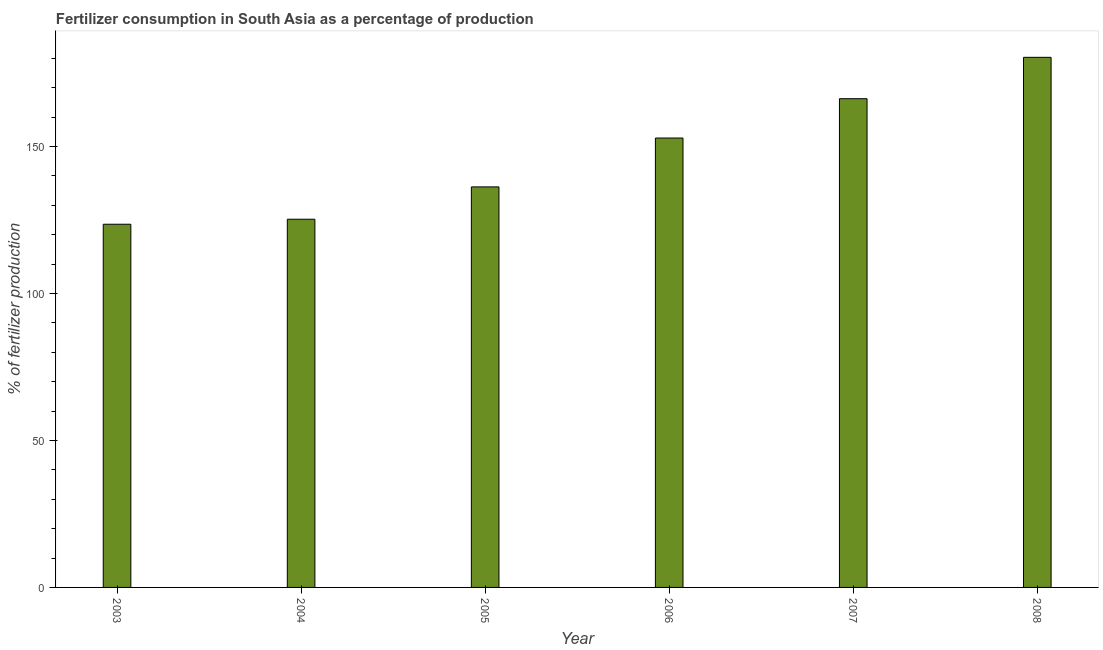Does the graph contain any zero values?
Make the answer very short. No. Does the graph contain grids?
Your response must be concise. No. What is the title of the graph?
Keep it short and to the point. Fertilizer consumption in South Asia as a percentage of production. What is the label or title of the X-axis?
Your answer should be compact. Year. What is the label or title of the Y-axis?
Provide a short and direct response. % of fertilizer production. What is the amount of fertilizer consumption in 2008?
Your answer should be very brief. 180.31. Across all years, what is the maximum amount of fertilizer consumption?
Offer a very short reply. 180.31. Across all years, what is the minimum amount of fertilizer consumption?
Give a very brief answer. 123.54. In which year was the amount of fertilizer consumption minimum?
Your response must be concise. 2003. What is the sum of the amount of fertilizer consumption?
Your response must be concise. 884.42. What is the difference between the amount of fertilizer consumption in 2003 and 2005?
Give a very brief answer. -12.7. What is the average amount of fertilizer consumption per year?
Your response must be concise. 147.4. What is the median amount of fertilizer consumption?
Provide a succinct answer. 144.55. What is the ratio of the amount of fertilizer consumption in 2006 to that in 2008?
Ensure brevity in your answer.  0.85. Is the difference between the amount of fertilizer consumption in 2005 and 2006 greater than the difference between any two years?
Offer a terse response. No. What is the difference between the highest and the second highest amount of fertilizer consumption?
Give a very brief answer. 14.07. Is the sum of the amount of fertilizer consumption in 2004 and 2007 greater than the maximum amount of fertilizer consumption across all years?
Provide a short and direct response. Yes. What is the difference between the highest and the lowest amount of fertilizer consumption?
Ensure brevity in your answer.  56.77. In how many years, is the amount of fertilizer consumption greater than the average amount of fertilizer consumption taken over all years?
Provide a succinct answer. 3. What is the difference between two consecutive major ticks on the Y-axis?
Provide a succinct answer. 50. What is the % of fertilizer production of 2003?
Your answer should be compact. 123.54. What is the % of fertilizer production of 2004?
Your answer should be compact. 125.24. What is the % of fertilizer production of 2005?
Your response must be concise. 136.23. What is the % of fertilizer production in 2006?
Your answer should be very brief. 152.86. What is the % of fertilizer production of 2007?
Offer a very short reply. 166.24. What is the % of fertilizer production in 2008?
Your answer should be compact. 180.31. What is the difference between the % of fertilizer production in 2003 and 2004?
Make the answer very short. -1.7. What is the difference between the % of fertilizer production in 2003 and 2005?
Provide a short and direct response. -12.7. What is the difference between the % of fertilizer production in 2003 and 2006?
Offer a terse response. -29.32. What is the difference between the % of fertilizer production in 2003 and 2007?
Keep it short and to the point. -42.7. What is the difference between the % of fertilizer production in 2003 and 2008?
Keep it short and to the point. -56.77. What is the difference between the % of fertilizer production in 2004 and 2005?
Keep it short and to the point. -10.99. What is the difference between the % of fertilizer production in 2004 and 2006?
Give a very brief answer. -27.62. What is the difference between the % of fertilizer production in 2004 and 2007?
Give a very brief answer. -41. What is the difference between the % of fertilizer production in 2004 and 2008?
Give a very brief answer. -55.07. What is the difference between the % of fertilizer production in 2005 and 2006?
Offer a very short reply. -16.63. What is the difference between the % of fertilizer production in 2005 and 2007?
Provide a succinct answer. -30. What is the difference between the % of fertilizer production in 2005 and 2008?
Offer a terse response. -44.07. What is the difference between the % of fertilizer production in 2006 and 2007?
Your answer should be very brief. -13.38. What is the difference between the % of fertilizer production in 2006 and 2008?
Offer a terse response. -27.45. What is the difference between the % of fertilizer production in 2007 and 2008?
Provide a short and direct response. -14.07. What is the ratio of the % of fertilizer production in 2003 to that in 2004?
Your answer should be compact. 0.99. What is the ratio of the % of fertilizer production in 2003 to that in 2005?
Provide a succinct answer. 0.91. What is the ratio of the % of fertilizer production in 2003 to that in 2006?
Your answer should be compact. 0.81. What is the ratio of the % of fertilizer production in 2003 to that in 2007?
Make the answer very short. 0.74. What is the ratio of the % of fertilizer production in 2003 to that in 2008?
Provide a succinct answer. 0.69. What is the ratio of the % of fertilizer production in 2004 to that in 2005?
Your response must be concise. 0.92. What is the ratio of the % of fertilizer production in 2004 to that in 2006?
Provide a succinct answer. 0.82. What is the ratio of the % of fertilizer production in 2004 to that in 2007?
Offer a very short reply. 0.75. What is the ratio of the % of fertilizer production in 2004 to that in 2008?
Offer a very short reply. 0.69. What is the ratio of the % of fertilizer production in 2005 to that in 2006?
Keep it short and to the point. 0.89. What is the ratio of the % of fertilizer production in 2005 to that in 2007?
Provide a succinct answer. 0.82. What is the ratio of the % of fertilizer production in 2005 to that in 2008?
Provide a succinct answer. 0.76. What is the ratio of the % of fertilizer production in 2006 to that in 2008?
Provide a succinct answer. 0.85. What is the ratio of the % of fertilizer production in 2007 to that in 2008?
Give a very brief answer. 0.92. 